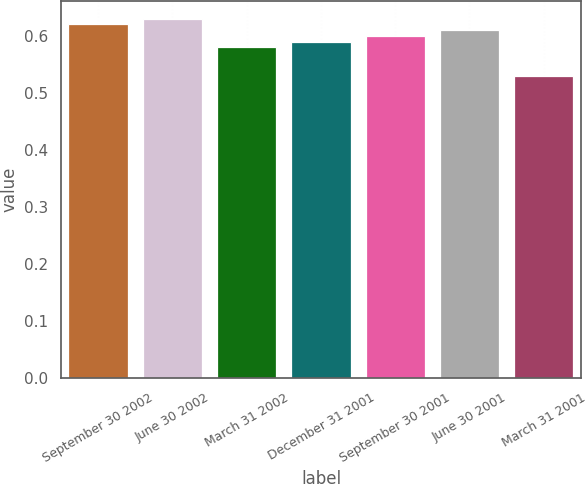Convert chart to OTSL. <chart><loc_0><loc_0><loc_500><loc_500><bar_chart><fcel>September 30 2002<fcel>June 30 2002<fcel>March 31 2002<fcel>December 31 2001<fcel>September 30 2001<fcel>June 30 2001<fcel>March 31 2001<nl><fcel>0.62<fcel>0.63<fcel>0.58<fcel>0.59<fcel>0.6<fcel>0.61<fcel>0.53<nl></chart> 